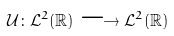Convert formula to latex. <formula><loc_0><loc_0><loc_500><loc_500>\mathcal { U } \colon \mathcal { L } ^ { 2 } ( \mathbb { R } ) \longrightarrow \mathcal { L } ^ { 2 } ( \mathbb { R } )</formula> 